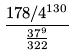Convert formula to latex. <formula><loc_0><loc_0><loc_500><loc_500>\frac { 1 7 8 / 4 ^ { 1 3 0 } } { \frac { 3 7 ^ { 9 } } { 3 2 2 } }</formula> 